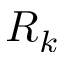Convert formula to latex. <formula><loc_0><loc_0><loc_500><loc_500>R _ { k }</formula> 